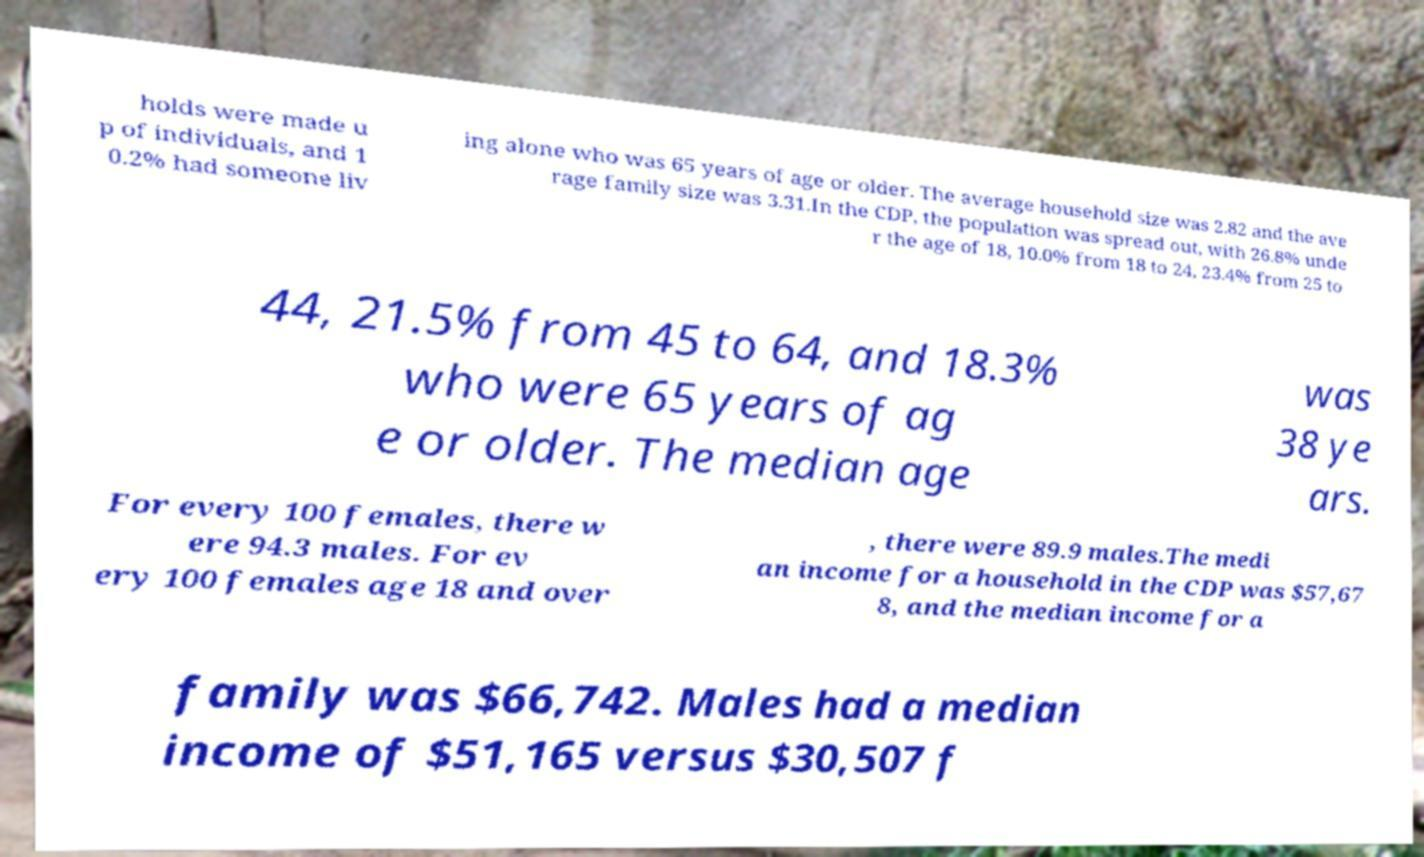There's text embedded in this image that I need extracted. Can you transcribe it verbatim? holds were made u p of individuals, and 1 0.2% had someone liv ing alone who was 65 years of age or older. The average household size was 2.82 and the ave rage family size was 3.31.In the CDP, the population was spread out, with 26.8% unde r the age of 18, 10.0% from 18 to 24, 23.4% from 25 to 44, 21.5% from 45 to 64, and 18.3% who were 65 years of ag e or older. The median age was 38 ye ars. For every 100 females, there w ere 94.3 males. For ev ery 100 females age 18 and over , there were 89.9 males.The medi an income for a household in the CDP was $57,67 8, and the median income for a family was $66,742. Males had a median income of $51,165 versus $30,507 f 